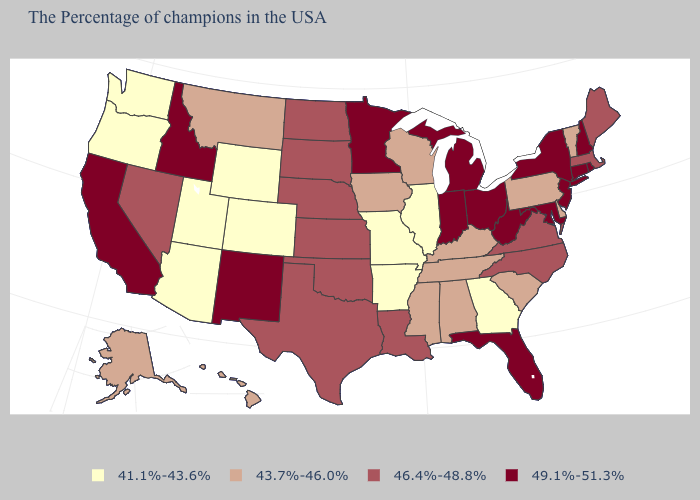Among the states that border Massachusetts , does Vermont have the lowest value?
Give a very brief answer. Yes. Does Alaska have the same value as Delaware?
Quick response, please. Yes. How many symbols are there in the legend?
Short answer required. 4. Among the states that border Tennessee , does Virginia have the highest value?
Keep it brief. Yes. Name the states that have a value in the range 46.4%-48.8%?
Short answer required. Maine, Massachusetts, Virginia, North Carolina, Louisiana, Kansas, Nebraska, Oklahoma, Texas, South Dakota, North Dakota, Nevada. Which states hav the highest value in the West?
Be succinct. New Mexico, Idaho, California. What is the lowest value in the Northeast?
Concise answer only. 43.7%-46.0%. What is the value of Indiana?
Keep it brief. 49.1%-51.3%. Which states have the highest value in the USA?
Keep it brief. Rhode Island, New Hampshire, Connecticut, New York, New Jersey, Maryland, West Virginia, Ohio, Florida, Michigan, Indiana, Minnesota, New Mexico, Idaho, California. What is the value of Kentucky?
Concise answer only. 43.7%-46.0%. What is the value of New York?
Write a very short answer. 49.1%-51.3%. What is the value of Minnesota?
Quick response, please. 49.1%-51.3%. Name the states that have a value in the range 49.1%-51.3%?
Short answer required. Rhode Island, New Hampshire, Connecticut, New York, New Jersey, Maryland, West Virginia, Ohio, Florida, Michigan, Indiana, Minnesota, New Mexico, Idaho, California. What is the lowest value in the USA?
Keep it brief. 41.1%-43.6%. What is the value of Delaware?
Write a very short answer. 43.7%-46.0%. 